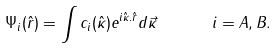Convert formula to latex. <formula><loc_0><loc_0><loc_500><loc_500>\Psi _ { i } ( \hat { r } ) = \int c _ { i } ( \hat { \kappa } ) e ^ { i \hat { \kappa } . \hat { r } } d \vec { \kappa } \quad \ \ i = A , B .</formula> 